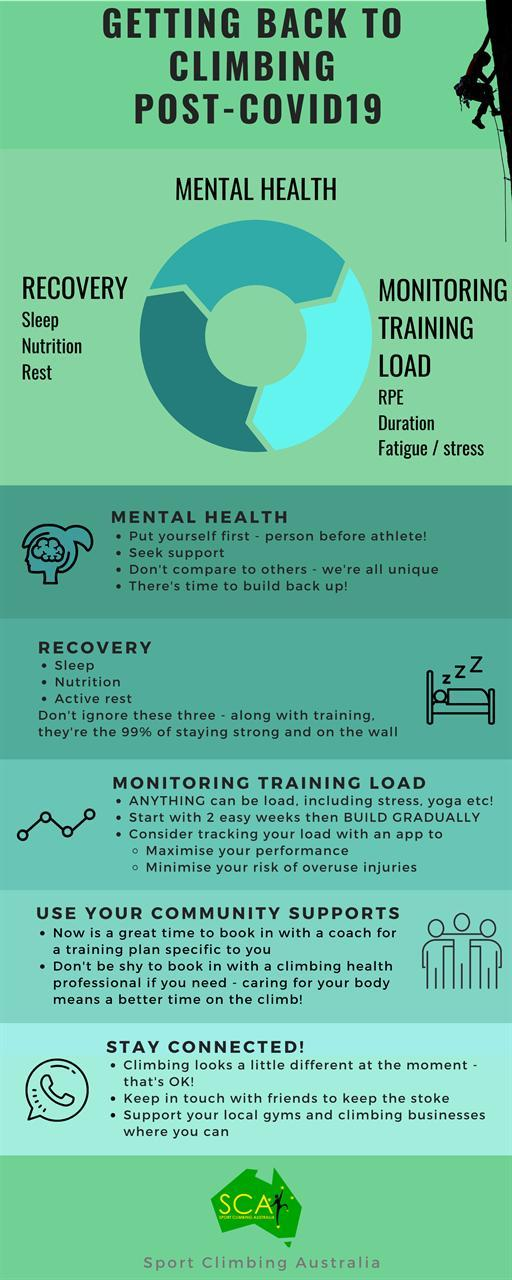How many tips are mentioned to improve mental health?
Answer the question with a short phrase. 4 How many points mentioned under Monitor Training Load? 3 Which three factors are necessary for recovery? sleep, nutrition, rest What is the second tip mentioned under mental health? Seek support 